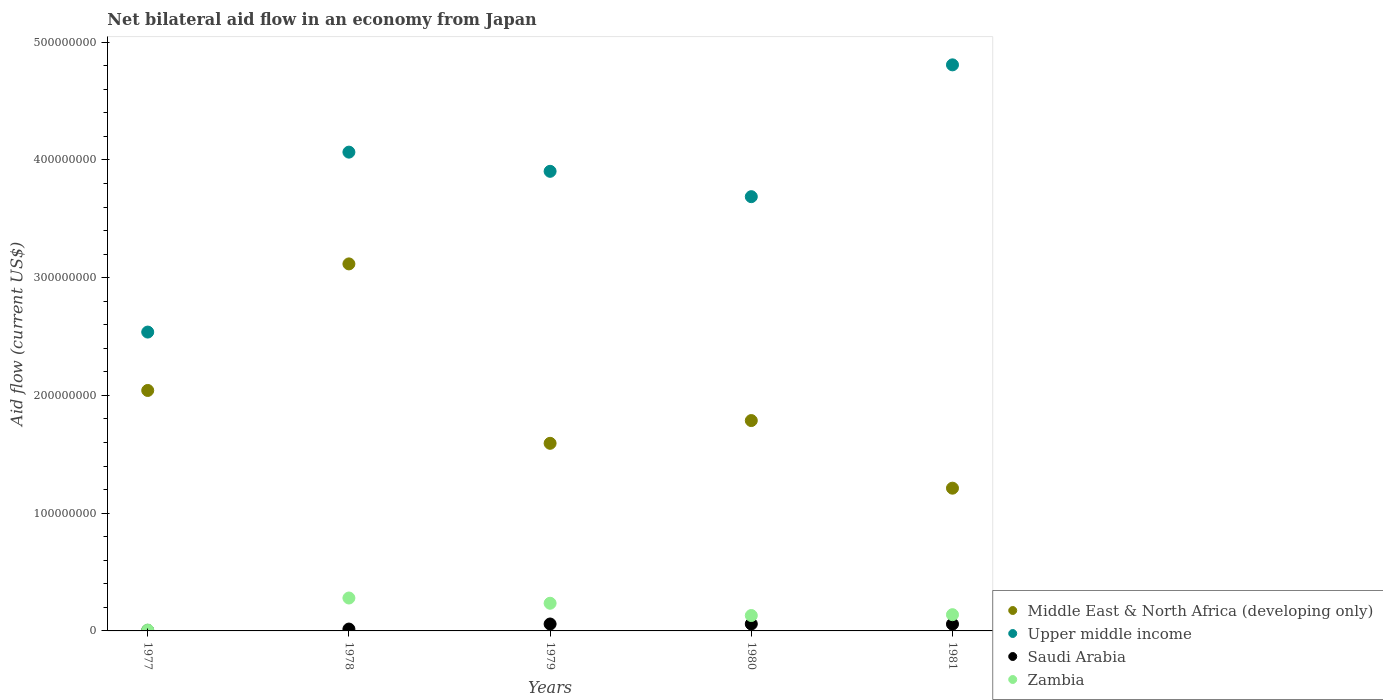What is the net bilateral aid flow in Upper middle income in 1980?
Your answer should be compact. 3.69e+08. Across all years, what is the maximum net bilateral aid flow in Middle East & North Africa (developing only)?
Keep it short and to the point. 3.12e+08. Across all years, what is the minimum net bilateral aid flow in Saudi Arabia?
Your response must be concise. 4.60e+05. In which year was the net bilateral aid flow in Saudi Arabia maximum?
Offer a terse response. 1980. In which year was the net bilateral aid flow in Zambia minimum?
Ensure brevity in your answer.  1977. What is the total net bilateral aid flow in Saudi Arabia in the graph?
Your response must be concise. 1.96e+07. What is the difference between the net bilateral aid flow in Saudi Arabia in 1979 and the net bilateral aid flow in Zambia in 1977?
Offer a terse response. 5.13e+06. What is the average net bilateral aid flow in Middle East & North Africa (developing only) per year?
Your answer should be very brief. 1.95e+08. In the year 1980, what is the difference between the net bilateral aid flow in Zambia and net bilateral aid flow in Upper middle income?
Ensure brevity in your answer.  -3.56e+08. What is the ratio of the net bilateral aid flow in Zambia in 1978 to that in 1981?
Offer a terse response. 2.03. Is the net bilateral aid flow in Zambia in 1980 less than that in 1981?
Your response must be concise. Yes. Is the difference between the net bilateral aid flow in Zambia in 1977 and 1979 greater than the difference between the net bilateral aid flow in Upper middle income in 1977 and 1979?
Provide a short and direct response. Yes. What is the difference between the highest and the second highest net bilateral aid flow in Zambia?
Your answer should be very brief. 4.45e+06. What is the difference between the highest and the lowest net bilateral aid flow in Upper middle income?
Give a very brief answer. 2.27e+08. Is the sum of the net bilateral aid flow in Middle East & North Africa (developing only) in 1978 and 1981 greater than the maximum net bilateral aid flow in Zambia across all years?
Provide a short and direct response. Yes. Is it the case that in every year, the sum of the net bilateral aid flow in Upper middle income and net bilateral aid flow in Middle East & North Africa (developing only)  is greater than the sum of net bilateral aid flow in Saudi Arabia and net bilateral aid flow in Zambia?
Make the answer very short. No. Is it the case that in every year, the sum of the net bilateral aid flow in Middle East & North Africa (developing only) and net bilateral aid flow in Saudi Arabia  is greater than the net bilateral aid flow in Upper middle income?
Provide a succinct answer. No. Is the net bilateral aid flow in Upper middle income strictly greater than the net bilateral aid flow in Middle East & North Africa (developing only) over the years?
Provide a succinct answer. Yes. How many years are there in the graph?
Keep it short and to the point. 5. Are the values on the major ticks of Y-axis written in scientific E-notation?
Provide a succinct answer. No. Does the graph contain grids?
Offer a very short reply. No. Where does the legend appear in the graph?
Ensure brevity in your answer.  Bottom right. How many legend labels are there?
Offer a terse response. 4. How are the legend labels stacked?
Your answer should be very brief. Vertical. What is the title of the graph?
Offer a terse response. Net bilateral aid flow in an economy from Japan. What is the label or title of the Y-axis?
Your answer should be compact. Aid flow (current US$). What is the Aid flow (current US$) of Middle East & North Africa (developing only) in 1977?
Give a very brief answer. 2.04e+08. What is the Aid flow (current US$) of Upper middle income in 1977?
Your response must be concise. 2.54e+08. What is the Aid flow (current US$) of Zambia in 1977?
Provide a short and direct response. 7.50e+05. What is the Aid flow (current US$) in Middle East & North Africa (developing only) in 1978?
Offer a very short reply. 3.12e+08. What is the Aid flow (current US$) in Upper middle income in 1978?
Make the answer very short. 4.07e+08. What is the Aid flow (current US$) in Saudi Arabia in 1978?
Provide a short and direct response. 1.58e+06. What is the Aid flow (current US$) of Zambia in 1978?
Keep it short and to the point. 2.80e+07. What is the Aid flow (current US$) of Middle East & North Africa (developing only) in 1979?
Make the answer very short. 1.59e+08. What is the Aid flow (current US$) in Upper middle income in 1979?
Make the answer very short. 3.90e+08. What is the Aid flow (current US$) in Saudi Arabia in 1979?
Your answer should be very brief. 5.88e+06. What is the Aid flow (current US$) in Zambia in 1979?
Keep it short and to the point. 2.35e+07. What is the Aid flow (current US$) of Middle East & North Africa (developing only) in 1980?
Your answer should be compact. 1.79e+08. What is the Aid flow (current US$) of Upper middle income in 1980?
Your answer should be very brief. 3.69e+08. What is the Aid flow (current US$) of Saudi Arabia in 1980?
Your answer should be very brief. 5.92e+06. What is the Aid flow (current US$) in Zambia in 1980?
Offer a very short reply. 1.31e+07. What is the Aid flow (current US$) of Middle East & North Africa (developing only) in 1981?
Offer a terse response. 1.21e+08. What is the Aid flow (current US$) in Upper middle income in 1981?
Make the answer very short. 4.81e+08. What is the Aid flow (current US$) of Saudi Arabia in 1981?
Provide a succinct answer. 5.78e+06. What is the Aid flow (current US$) in Zambia in 1981?
Offer a very short reply. 1.38e+07. Across all years, what is the maximum Aid flow (current US$) of Middle East & North Africa (developing only)?
Your response must be concise. 3.12e+08. Across all years, what is the maximum Aid flow (current US$) of Upper middle income?
Provide a short and direct response. 4.81e+08. Across all years, what is the maximum Aid flow (current US$) of Saudi Arabia?
Your response must be concise. 5.92e+06. Across all years, what is the maximum Aid flow (current US$) in Zambia?
Offer a very short reply. 2.80e+07. Across all years, what is the minimum Aid flow (current US$) of Middle East & North Africa (developing only)?
Keep it short and to the point. 1.21e+08. Across all years, what is the minimum Aid flow (current US$) of Upper middle income?
Ensure brevity in your answer.  2.54e+08. Across all years, what is the minimum Aid flow (current US$) in Saudi Arabia?
Your response must be concise. 4.60e+05. Across all years, what is the minimum Aid flow (current US$) of Zambia?
Give a very brief answer. 7.50e+05. What is the total Aid flow (current US$) in Middle East & North Africa (developing only) in the graph?
Ensure brevity in your answer.  9.75e+08. What is the total Aid flow (current US$) in Upper middle income in the graph?
Keep it short and to the point. 1.90e+09. What is the total Aid flow (current US$) in Saudi Arabia in the graph?
Provide a short and direct response. 1.96e+07. What is the total Aid flow (current US$) of Zambia in the graph?
Ensure brevity in your answer.  7.91e+07. What is the difference between the Aid flow (current US$) of Middle East & North Africa (developing only) in 1977 and that in 1978?
Ensure brevity in your answer.  -1.07e+08. What is the difference between the Aid flow (current US$) of Upper middle income in 1977 and that in 1978?
Offer a terse response. -1.53e+08. What is the difference between the Aid flow (current US$) in Saudi Arabia in 1977 and that in 1978?
Give a very brief answer. -1.12e+06. What is the difference between the Aid flow (current US$) in Zambia in 1977 and that in 1978?
Give a very brief answer. -2.72e+07. What is the difference between the Aid flow (current US$) in Middle East & North Africa (developing only) in 1977 and that in 1979?
Make the answer very short. 4.49e+07. What is the difference between the Aid flow (current US$) in Upper middle income in 1977 and that in 1979?
Your answer should be compact. -1.37e+08. What is the difference between the Aid flow (current US$) of Saudi Arabia in 1977 and that in 1979?
Your answer should be compact. -5.42e+06. What is the difference between the Aid flow (current US$) in Zambia in 1977 and that in 1979?
Offer a very short reply. -2.28e+07. What is the difference between the Aid flow (current US$) in Middle East & North Africa (developing only) in 1977 and that in 1980?
Provide a succinct answer. 2.56e+07. What is the difference between the Aid flow (current US$) in Upper middle income in 1977 and that in 1980?
Give a very brief answer. -1.15e+08. What is the difference between the Aid flow (current US$) of Saudi Arabia in 1977 and that in 1980?
Keep it short and to the point. -5.46e+06. What is the difference between the Aid flow (current US$) of Zambia in 1977 and that in 1980?
Make the answer very short. -1.23e+07. What is the difference between the Aid flow (current US$) in Middle East & North Africa (developing only) in 1977 and that in 1981?
Give a very brief answer. 8.30e+07. What is the difference between the Aid flow (current US$) in Upper middle income in 1977 and that in 1981?
Make the answer very short. -2.27e+08. What is the difference between the Aid flow (current US$) in Saudi Arabia in 1977 and that in 1981?
Offer a terse response. -5.32e+06. What is the difference between the Aid flow (current US$) of Zambia in 1977 and that in 1981?
Keep it short and to the point. -1.30e+07. What is the difference between the Aid flow (current US$) of Middle East & North Africa (developing only) in 1978 and that in 1979?
Give a very brief answer. 1.52e+08. What is the difference between the Aid flow (current US$) of Upper middle income in 1978 and that in 1979?
Provide a succinct answer. 1.63e+07. What is the difference between the Aid flow (current US$) in Saudi Arabia in 1978 and that in 1979?
Provide a short and direct response. -4.30e+06. What is the difference between the Aid flow (current US$) of Zambia in 1978 and that in 1979?
Offer a very short reply. 4.45e+06. What is the difference between the Aid flow (current US$) of Middle East & North Africa (developing only) in 1978 and that in 1980?
Offer a terse response. 1.33e+08. What is the difference between the Aid flow (current US$) of Upper middle income in 1978 and that in 1980?
Give a very brief answer. 3.78e+07. What is the difference between the Aid flow (current US$) of Saudi Arabia in 1978 and that in 1980?
Your answer should be very brief. -4.34e+06. What is the difference between the Aid flow (current US$) in Zambia in 1978 and that in 1980?
Make the answer very short. 1.49e+07. What is the difference between the Aid flow (current US$) in Middle East & North Africa (developing only) in 1978 and that in 1981?
Keep it short and to the point. 1.90e+08. What is the difference between the Aid flow (current US$) of Upper middle income in 1978 and that in 1981?
Give a very brief answer. -7.41e+07. What is the difference between the Aid flow (current US$) in Saudi Arabia in 1978 and that in 1981?
Your response must be concise. -4.20e+06. What is the difference between the Aid flow (current US$) of Zambia in 1978 and that in 1981?
Your answer should be compact. 1.42e+07. What is the difference between the Aid flow (current US$) in Middle East & North Africa (developing only) in 1979 and that in 1980?
Ensure brevity in your answer.  -1.93e+07. What is the difference between the Aid flow (current US$) in Upper middle income in 1979 and that in 1980?
Provide a succinct answer. 2.15e+07. What is the difference between the Aid flow (current US$) of Saudi Arabia in 1979 and that in 1980?
Offer a terse response. -4.00e+04. What is the difference between the Aid flow (current US$) of Zambia in 1979 and that in 1980?
Your response must be concise. 1.04e+07. What is the difference between the Aid flow (current US$) in Middle East & North Africa (developing only) in 1979 and that in 1981?
Make the answer very short. 3.81e+07. What is the difference between the Aid flow (current US$) of Upper middle income in 1979 and that in 1981?
Provide a short and direct response. -9.04e+07. What is the difference between the Aid flow (current US$) in Zambia in 1979 and that in 1981?
Offer a very short reply. 9.71e+06. What is the difference between the Aid flow (current US$) of Middle East & North Africa (developing only) in 1980 and that in 1981?
Keep it short and to the point. 5.74e+07. What is the difference between the Aid flow (current US$) of Upper middle income in 1980 and that in 1981?
Provide a succinct answer. -1.12e+08. What is the difference between the Aid flow (current US$) in Zambia in 1980 and that in 1981?
Your answer should be compact. -7.10e+05. What is the difference between the Aid flow (current US$) of Middle East & North Africa (developing only) in 1977 and the Aid flow (current US$) of Upper middle income in 1978?
Provide a short and direct response. -2.02e+08. What is the difference between the Aid flow (current US$) in Middle East & North Africa (developing only) in 1977 and the Aid flow (current US$) in Saudi Arabia in 1978?
Offer a terse response. 2.03e+08. What is the difference between the Aid flow (current US$) of Middle East & North Africa (developing only) in 1977 and the Aid flow (current US$) of Zambia in 1978?
Offer a very short reply. 1.76e+08. What is the difference between the Aid flow (current US$) in Upper middle income in 1977 and the Aid flow (current US$) in Saudi Arabia in 1978?
Make the answer very short. 2.52e+08. What is the difference between the Aid flow (current US$) of Upper middle income in 1977 and the Aid flow (current US$) of Zambia in 1978?
Make the answer very short. 2.26e+08. What is the difference between the Aid flow (current US$) in Saudi Arabia in 1977 and the Aid flow (current US$) in Zambia in 1978?
Make the answer very short. -2.75e+07. What is the difference between the Aid flow (current US$) in Middle East & North Africa (developing only) in 1977 and the Aid flow (current US$) in Upper middle income in 1979?
Provide a short and direct response. -1.86e+08. What is the difference between the Aid flow (current US$) in Middle East & North Africa (developing only) in 1977 and the Aid flow (current US$) in Saudi Arabia in 1979?
Your answer should be compact. 1.98e+08. What is the difference between the Aid flow (current US$) in Middle East & North Africa (developing only) in 1977 and the Aid flow (current US$) in Zambia in 1979?
Offer a terse response. 1.81e+08. What is the difference between the Aid flow (current US$) in Upper middle income in 1977 and the Aid flow (current US$) in Saudi Arabia in 1979?
Ensure brevity in your answer.  2.48e+08. What is the difference between the Aid flow (current US$) of Upper middle income in 1977 and the Aid flow (current US$) of Zambia in 1979?
Make the answer very short. 2.30e+08. What is the difference between the Aid flow (current US$) of Saudi Arabia in 1977 and the Aid flow (current US$) of Zambia in 1979?
Provide a succinct answer. -2.30e+07. What is the difference between the Aid flow (current US$) of Middle East & North Africa (developing only) in 1977 and the Aid flow (current US$) of Upper middle income in 1980?
Offer a very short reply. -1.65e+08. What is the difference between the Aid flow (current US$) of Middle East & North Africa (developing only) in 1977 and the Aid flow (current US$) of Saudi Arabia in 1980?
Provide a succinct answer. 1.98e+08. What is the difference between the Aid flow (current US$) in Middle East & North Africa (developing only) in 1977 and the Aid flow (current US$) in Zambia in 1980?
Provide a succinct answer. 1.91e+08. What is the difference between the Aid flow (current US$) of Upper middle income in 1977 and the Aid flow (current US$) of Saudi Arabia in 1980?
Ensure brevity in your answer.  2.48e+08. What is the difference between the Aid flow (current US$) in Upper middle income in 1977 and the Aid flow (current US$) in Zambia in 1980?
Provide a succinct answer. 2.41e+08. What is the difference between the Aid flow (current US$) of Saudi Arabia in 1977 and the Aid flow (current US$) of Zambia in 1980?
Ensure brevity in your answer.  -1.26e+07. What is the difference between the Aid flow (current US$) in Middle East & North Africa (developing only) in 1977 and the Aid flow (current US$) in Upper middle income in 1981?
Offer a very short reply. -2.77e+08. What is the difference between the Aid flow (current US$) of Middle East & North Africa (developing only) in 1977 and the Aid flow (current US$) of Saudi Arabia in 1981?
Your response must be concise. 1.98e+08. What is the difference between the Aid flow (current US$) of Middle East & North Africa (developing only) in 1977 and the Aid flow (current US$) of Zambia in 1981?
Offer a terse response. 1.90e+08. What is the difference between the Aid flow (current US$) of Upper middle income in 1977 and the Aid flow (current US$) of Saudi Arabia in 1981?
Offer a very short reply. 2.48e+08. What is the difference between the Aid flow (current US$) of Upper middle income in 1977 and the Aid flow (current US$) of Zambia in 1981?
Ensure brevity in your answer.  2.40e+08. What is the difference between the Aid flow (current US$) in Saudi Arabia in 1977 and the Aid flow (current US$) in Zambia in 1981?
Keep it short and to the point. -1.33e+07. What is the difference between the Aid flow (current US$) in Middle East & North Africa (developing only) in 1978 and the Aid flow (current US$) in Upper middle income in 1979?
Offer a terse response. -7.86e+07. What is the difference between the Aid flow (current US$) in Middle East & North Africa (developing only) in 1978 and the Aid flow (current US$) in Saudi Arabia in 1979?
Ensure brevity in your answer.  3.06e+08. What is the difference between the Aid flow (current US$) in Middle East & North Africa (developing only) in 1978 and the Aid flow (current US$) in Zambia in 1979?
Offer a terse response. 2.88e+08. What is the difference between the Aid flow (current US$) of Upper middle income in 1978 and the Aid flow (current US$) of Saudi Arabia in 1979?
Offer a very short reply. 4.01e+08. What is the difference between the Aid flow (current US$) of Upper middle income in 1978 and the Aid flow (current US$) of Zambia in 1979?
Make the answer very short. 3.83e+08. What is the difference between the Aid flow (current US$) in Saudi Arabia in 1978 and the Aid flow (current US$) in Zambia in 1979?
Keep it short and to the point. -2.19e+07. What is the difference between the Aid flow (current US$) of Middle East & North Africa (developing only) in 1978 and the Aid flow (current US$) of Upper middle income in 1980?
Provide a short and direct response. -5.71e+07. What is the difference between the Aid flow (current US$) of Middle East & North Africa (developing only) in 1978 and the Aid flow (current US$) of Saudi Arabia in 1980?
Provide a short and direct response. 3.06e+08. What is the difference between the Aid flow (current US$) in Middle East & North Africa (developing only) in 1978 and the Aid flow (current US$) in Zambia in 1980?
Offer a very short reply. 2.99e+08. What is the difference between the Aid flow (current US$) of Upper middle income in 1978 and the Aid flow (current US$) of Saudi Arabia in 1980?
Offer a very short reply. 4.01e+08. What is the difference between the Aid flow (current US$) in Upper middle income in 1978 and the Aid flow (current US$) in Zambia in 1980?
Provide a short and direct response. 3.94e+08. What is the difference between the Aid flow (current US$) of Saudi Arabia in 1978 and the Aid flow (current US$) of Zambia in 1980?
Your response must be concise. -1.15e+07. What is the difference between the Aid flow (current US$) of Middle East & North Africa (developing only) in 1978 and the Aid flow (current US$) of Upper middle income in 1981?
Your response must be concise. -1.69e+08. What is the difference between the Aid flow (current US$) in Middle East & North Africa (developing only) in 1978 and the Aid flow (current US$) in Saudi Arabia in 1981?
Give a very brief answer. 3.06e+08. What is the difference between the Aid flow (current US$) of Middle East & North Africa (developing only) in 1978 and the Aid flow (current US$) of Zambia in 1981?
Provide a succinct answer. 2.98e+08. What is the difference between the Aid flow (current US$) of Upper middle income in 1978 and the Aid flow (current US$) of Saudi Arabia in 1981?
Make the answer very short. 4.01e+08. What is the difference between the Aid flow (current US$) in Upper middle income in 1978 and the Aid flow (current US$) in Zambia in 1981?
Offer a very short reply. 3.93e+08. What is the difference between the Aid flow (current US$) in Saudi Arabia in 1978 and the Aid flow (current US$) in Zambia in 1981?
Offer a very short reply. -1.22e+07. What is the difference between the Aid flow (current US$) of Middle East & North Africa (developing only) in 1979 and the Aid flow (current US$) of Upper middle income in 1980?
Your response must be concise. -2.09e+08. What is the difference between the Aid flow (current US$) in Middle East & North Africa (developing only) in 1979 and the Aid flow (current US$) in Saudi Arabia in 1980?
Provide a short and direct response. 1.53e+08. What is the difference between the Aid flow (current US$) of Middle East & North Africa (developing only) in 1979 and the Aid flow (current US$) of Zambia in 1980?
Your response must be concise. 1.46e+08. What is the difference between the Aid flow (current US$) of Upper middle income in 1979 and the Aid flow (current US$) of Saudi Arabia in 1980?
Your response must be concise. 3.84e+08. What is the difference between the Aid flow (current US$) in Upper middle income in 1979 and the Aid flow (current US$) in Zambia in 1980?
Keep it short and to the point. 3.77e+08. What is the difference between the Aid flow (current US$) in Saudi Arabia in 1979 and the Aid flow (current US$) in Zambia in 1980?
Your answer should be very brief. -7.20e+06. What is the difference between the Aid flow (current US$) of Middle East & North Africa (developing only) in 1979 and the Aid flow (current US$) of Upper middle income in 1981?
Give a very brief answer. -3.21e+08. What is the difference between the Aid flow (current US$) of Middle East & North Africa (developing only) in 1979 and the Aid flow (current US$) of Saudi Arabia in 1981?
Make the answer very short. 1.54e+08. What is the difference between the Aid flow (current US$) of Middle East & North Africa (developing only) in 1979 and the Aid flow (current US$) of Zambia in 1981?
Your answer should be compact. 1.46e+08. What is the difference between the Aid flow (current US$) of Upper middle income in 1979 and the Aid flow (current US$) of Saudi Arabia in 1981?
Keep it short and to the point. 3.85e+08. What is the difference between the Aid flow (current US$) of Upper middle income in 1979 and the Aid flow (current US$) of Zambia in 1981?
Give a very brief answer. 3.77e+08. What is the difference between the Aid flow (current US$) of Saudi Arabia in 1979 and the Aid flow (current US$) of Zambia in 1981?
Keep it short and to the point. -7.91e+06. What is the difference between the Aid flow (current US$) in Middle East & North Africa (developing only) in 1980 and the Aid flow (current US$) in Upper middle income in 1981?
Your answer should be compact. -3.02e+08. What is the difference between the Aid flow (current US$) in Middle East & North Africa (developing only) in 1980 and the Aid flow (current US$) in Saudi Arabia in 1981?
Offer a terse response. 1.73e+08. What is the difference between the Aid flow (current US$) of Middle East & North Africa (developing only) in 1980 and the Aid flow (current US$) of Zambia in 1981?
Make the answer very short. 1.65e+08. What is the difference between the Aid flow (current US$) of Upper middle income in 1980 and the Aid flow (current US$) of Saudi Arabia in 1981?
Your answer should be very brief. 3.63e+08. What is the difference between the Aid flow (current US$) of Upper middle income in 1980 and the Aid flow (current US$) of Zambia in 1981?
Keep it short and to the point. 3.55e+08. What is the difference between the Aid flow (current US$) of Saudi Arabia in 1980 and the Aid flow (current US$) of Zambia in 1981?
Your answer should be compact. -7.87e+06. What is the average Aid flow (current US$) in Middle East & North Africa (developing only) per year?
Provide a short and direct response. 1.95e+08. What is the average Aid flow (current US$) of Upper middle income per year?
Provide a short and direct response. 3.80e+08. What is the average Aid flow (current US$) of Saudi Arabia per year?
Your answer should be compact. 3.92e+06. What is the average Aid flow (current US$) in Zambia per year?
Provide a short and direct response. 1.58e+07. In the year 1977, what is the difference between the Aid flow (current US$) of Middle East & North Africa (developing only) and Aid flow (current US$) of Upper middle income?
Offer a very short reply. -4.96e+07. In the year 1977, what is the difference between the Aid flow (current US$) of Middle East & North Africa (developing only) and Aid flow (current US$) of Saudi Arabia?
Provide a short and direct response. 2.04e+08. In the year 1977, what is the difference between the Aid flow (current US$) in Middle East & North Africa (developing only) and Aid flow (current US$) in Zambia?
Provide a succinct answer. 2.03e+08. In the year 1977, what is the difference between the Aid flow (current US$) of Upper middle income and Aid flow (current US$) of Saudi Arabia?
Your answer should be compact. 2.53e+08. In the year 1977, what is the difference between the Aid flow (current US$) in Upper middle income and Aid flow (current US$) in Zambia?
Provide a succinct answer. 2.53e+08. In the year 1977, what is the difference between the Aid flow (current US$) of Saudi Arabia and Aid flow (current US$) of Zambia?
Keep it short and to the point. -2.90e+05. In the year 1978, what is the difference between the Aid flow (current US$) of Middle East & North Africa (developing only) and Aid flow (current US$) of Upper middle income?
Your response must be concise. -9.49e+07. In the year 1978, what is the difference between the Aid flow (current US$) in Middle East & North Africa (developing only) and Aid flow (current US$) in Saudi Arabia?
Make the answer very short. 3.10e+08. In the year 1978, what is the difference between the Aid flow (current US$) in Middle East & North Africa (developing only) and Aid flow (current US$) in Zambia?
Offer a terse response. 2.84e+08. In the year 1978, what is the difference between the Aid flow (current US$) of Upper middle income and Aid flow (current US$) of Saudi Arabia?
Offer a terse response. 4.05e+08. In the year 1978, what is the difference between the Aid flow (current US$) in Upper middle income and Aid flow (current US$) in Zambia?
Your answer should be compact. 3.79e+08. In the year 1978, what is the difference between the Aid flow (current US$) of Saudi Arabia and Aid flow (current US$) of Zambia?
Give a very brief answer. -2.64e+07. In the year 1979, what is the difference between the Aid flow (current US$) in Middle East & North Africa (developing only) and Aid flow (current US$) in Upper middle income?
Your response must be concise. -2.31e+08. In the year 1979, what is the difference between the Aid flow (current US$) in Middle East & North Africa (developing only) and Aid flow (current US$) in Saudi Arabia?
Give a very brief answer. 1.53e+08. In the year 1979, what is the difference between the Aid flow (current US$) in Middle East & North Africa (developing only) and Aid flow (current US$) in Zambia?
Keep it short and to the point. 1.36e+08. In the year 1979, what is the difference between the Aid flow (current US$) in Upper middle income and Aid flow (current US$) in Saudi Arabia?
Give a very brief answer. 3.84e+08. In the year 1979, what is the difference between the Aid flow (current US$) in Upper middle income and Aid flow (current US$) in Zambia?
Offer a terse response. 3.67e+08. In the year 1979, what is the difference between the Aid flow (current US$) in Saudi Arabia and Aid flow (current US$) in Zambia?
Offer a terse response. -1.76e+07. In the year 1980, what is the difference between the Aid flow (current US$) in Middle East & North Africa (developing only) and Aid flow (current US$) in Upper middle income?
Provide a short and direct response. -1.90e+08. In the year 1980, what is the difference between the Aid flow (current US$) in Middle East & North Africa (developing only) and Aid flow (current US$) in Saudi Arabia?
Keep it short and to the point. 1.73e+08. In the year 1980, what is the difference between the Aid flow (current US$) in Middle East & North Africa (developing only) and Aid flow (current US$) in Zambia?
Offer a terse response. 1.66e+08. In the year 1980, what is the difference between the Aid flow (current US$) of Upper middle income and Aid flow (current US$) of Saudi Arabia?
Your response must be concise. 3.63e+08. In the year 1980, what is the difference between the Aid flow (current US$) in Upper middle income and Aid flow (current US$) in Zambia?
Make the answer very short. 3.56e+08. In the year 1980, what is the difference between the Aid flow (current US$) of Saudi Arabia and Aid flow (current US$) of Zambia?
Your answer should be compact. -7.16e+06. In the year 1981, what is the difference between the Aid flow (current US$) in Middle East & North Africa (developing only) and Aid flow (current US$) in Upper middle income?
Offer a very short reply. -3.60e+08. In the year 1981, what is the difference between the Aid flow (current US$) of Middle East & North Africa (developing only) and Aid flow (current US$) of Saudi Arabia?
Ensure brevity in your answer.  1.15e+08. In the year 1981, what is the difference between the Aid flow (current US$) of Middle East & North Africa (developing only) and Aid flow (current US$) of Zambia?
Offer a very short reply. 1.07e+08. In the year 1981, what is the difference between the Aid flow (current US$) in Upper middle income and Aid flow (current US$) in Saudi Arabia?
Your answer should be very brief. 4.75e+08. In the year 1981, what is the difference between the Aid flow (current US$) of Upper middle income and Aid flow (current US$) of Zambia?
Offer a terse response. 4.67e+08. In the year 1981, what is the difference between the Aid flow (current US$) of Saudi Arabia and Aid flow (current US$) of Zambia?
Ensure brevity in your answer.  -8.01e+06. What is the ratio of the Aid flow (current US$) in Middle East & North Africa (developing only) in 1977 to that in 1978?
Ensure brevity in your answer.  0.66. What is the ratio of the Aid flow (current US$) in Upper middle income in 1977 to that in 1978?
Make the answer very short. 0.62. What is the ratio of the Aid flow (current US$) of Saudi Arabia in 1977 to that in 1978?
Ensure brevity in your answer.  0.29. What is the ratio of the Aid flow (current US$) in Zambia in 1977 to that in 1978?
Make the answer very short. 0.03. What is the ratio of the Aid flow (current US$) in Middle East & North Africa (developing only) in 1977 to that in 1979?
Your answer should be compact. 1.28. What is the ratio of the Aid flow (current US$) in Upper middle income in 1977 to that in 1979?
Keep it short and to the point. 0.65. What is the ratio of the Aid flow (current US$) in Saudi Arabia in 1977 to that in 1979?
Offer a very short reply. 0.08. What is the ratio of the Aid flow (current US$) of Zambia in 1977 to that in 1979?
Make the answer very short. 0.03. What is the ratio of the Aid flow (current US$) of Middle East & North Africa (developing only) in 1977 to that in 1980?
Offer a terse response. 1.14. What is the ratio of the Aid flow (current US$) in Upper middle income in 1977 to that in 1980?
Give a very brief answer. 0.69. What is the ratio of the Aid flow (current US$) of Saudi Arabia in 1977 to that in 1980?
Give a very brief answer. 0.08. What is the ratio of the Aid flow (current US$) of Zambia in 1977 to that in 1980?
Your answer should be compact. 0.06. What is the ratio of the Aid flow (current US$) of Middle East & North Africa (developing only) in 1977 to that in 1981?
Your answer should be very brief. 1.68. What is the ratio of the Aid flow (current US$) in Upper middle income in 1977 to that in 1981?
Offer a terse response. 0.53. What is the ratio of the Aid flow (current US$) of Saudi Arabia in 1977 to that in 1981?
Offer a very short reply. 0.08. What is the ratio of the Aid flow (current US$) in Zambia in 1977 to that in 1981?
Give a very brief answer. 0.05. What is the ratio of the Aid flow (current US$) in Middle East & North Africa (developing only) in 1978 to that in 1979?
Give a very brief answer. 1.96. What is the ratio of the Aid flow (current US$) of Upper middle income in 1978 to that in 1979?
Make the answer very short. 1.04. What is the ratio of the Aid flow (current US$) of Saudi Arabia in 1978 to that in 1979?
Provide a short and direct response. 0.27. What is the ratio of the Aid flow (current US$) in Zambia in 1978 to that in 1979?
Provide a succinct answer. 1.19. What is the ratio of the Aid flow (current US$) of Middle East & North Africa (developing only) in 1978 to that in 1980?
Your response must be concise. 1.74. What is the ratio of the Aid flow (current US$) of Upper middle income in 1978 to that in 1980?
Provide a succinct answer. 1.1. What is the ratio of the Aid flow (current US$) in Saudi Arabia in 1978 to that in 1980?
Your answer should be compact. 0.27. What is the ratio of the Aid flow (current US$) of Zambia in 1978 to that in 1980?
Your answer should be very brief. 2.14. What is the ratio of the Aid flow (current US$) of Middle East & North Africa (developing only) in 1978 to that in 1981?
Provide a short and direct response. 2.57. What is the ratio of the Aid flow (current US$) of Upper middle income in 1978 to that in 1981?
Provide a short and direct response. 0.85. What is the ratio of the Aid flow (current US$) of Saudi Arabia in 1978 to that in 1981?
Your response must be concise. 0.27. What is the ratio of the Aid flow (current US$) of Zambia in 1978 to that in 1981?
Make the answer very short. 2.03. What is the ratio of the Aid flow (current US$) in Middle East & North Africa (developing only) in 1979 to that in 1980?
Your answer should be very brief. 0.89. What is the ratio of the Aid flow (current US$) in Upper middle income in 1979 to that in 1980?
Offer a very short reply. 1.06. What is the ratio of the Aid flow (current US$) of Saudi Arabia in 1979 to that in 1980?
Offer a terse response. 0.99. What is the ratio of the Aid flow (current US$) of Zambia in 1979 to that in 1980?
Make the answer very short. 1.8. What is the ratio of the Aid flow (current US$) in Middle East & North Africa (developing only) in 1979 to that in 1981?
Your answer should be very brief. 1.31. What is the ratio of the Aid flow (current US$) of Upper middle income in 1979 to that in 1981?
Your answer should be compact. 0.81. What is the ratio of the Aid flow (current US$) of Saudi Arabia in 1979 to that in 1981?
Keep it short and to the point. 1.02. What is the ratio of the Aid flow (current US$) of Zambia in 1979 to that in 1981?
Give a very brief answer. 1.7. What is the ratio of the Aid flow (current US$) of Middle East & North Africa (developing only) in 1980 to that in 1981?
Your answer should be very brief. 1.47. What is the ratio of the Aid flow (current US$) of Upper middle income in 1980 to that in 1981?
Your response must be concise. 0.77. What is the ratio of the Aid flow (current US$) in Saudi Arabia in 1980 to that in 1981?
Make the answer very short. 1.02. What is the ratio of the Aid flow (current US$) in Zambia in 1980 to that in 1981?
Provide a succinct answer. 0.95. What is the difference between the highest and the second highest Aid flow (current US$) of Middle East & North Africa (developing only)?
Your answer should be very brief. 1.07e+08. What is the difference between the highest and the second highest Aid flow (current US$) of Upper middle income?
Your answer should be very brief. 7.41e+07. What is the difference between the highest and the second highest Aid flow (current US$) in Saudi Arabia?
Offer a very short reply. 4.00e+04. What is the difference between the highest and the second highest Aid flow (current US$) in Zambia?
Provide a short and direct response. 4.45e+06. What is the difference between the highest and the lowest Aid flow (current US$) of Middle East & North Africa (developing only)?
Offer a terse response. 1.90e+08. What is the difference between the highest and the lowest Aid flow (current US$) of Upper middle income?
Give a very brief answer. 2.27e+08. What is the difference between the highest and the lowest Aid flow (current US$) of Saudi Arabia?
Your answer should be very brief. 5.46e+06. What is the difference between the highest and the lowest Aid flow (current US$) in Zambia?
Provide a succinct answer. 2.72e+07. 